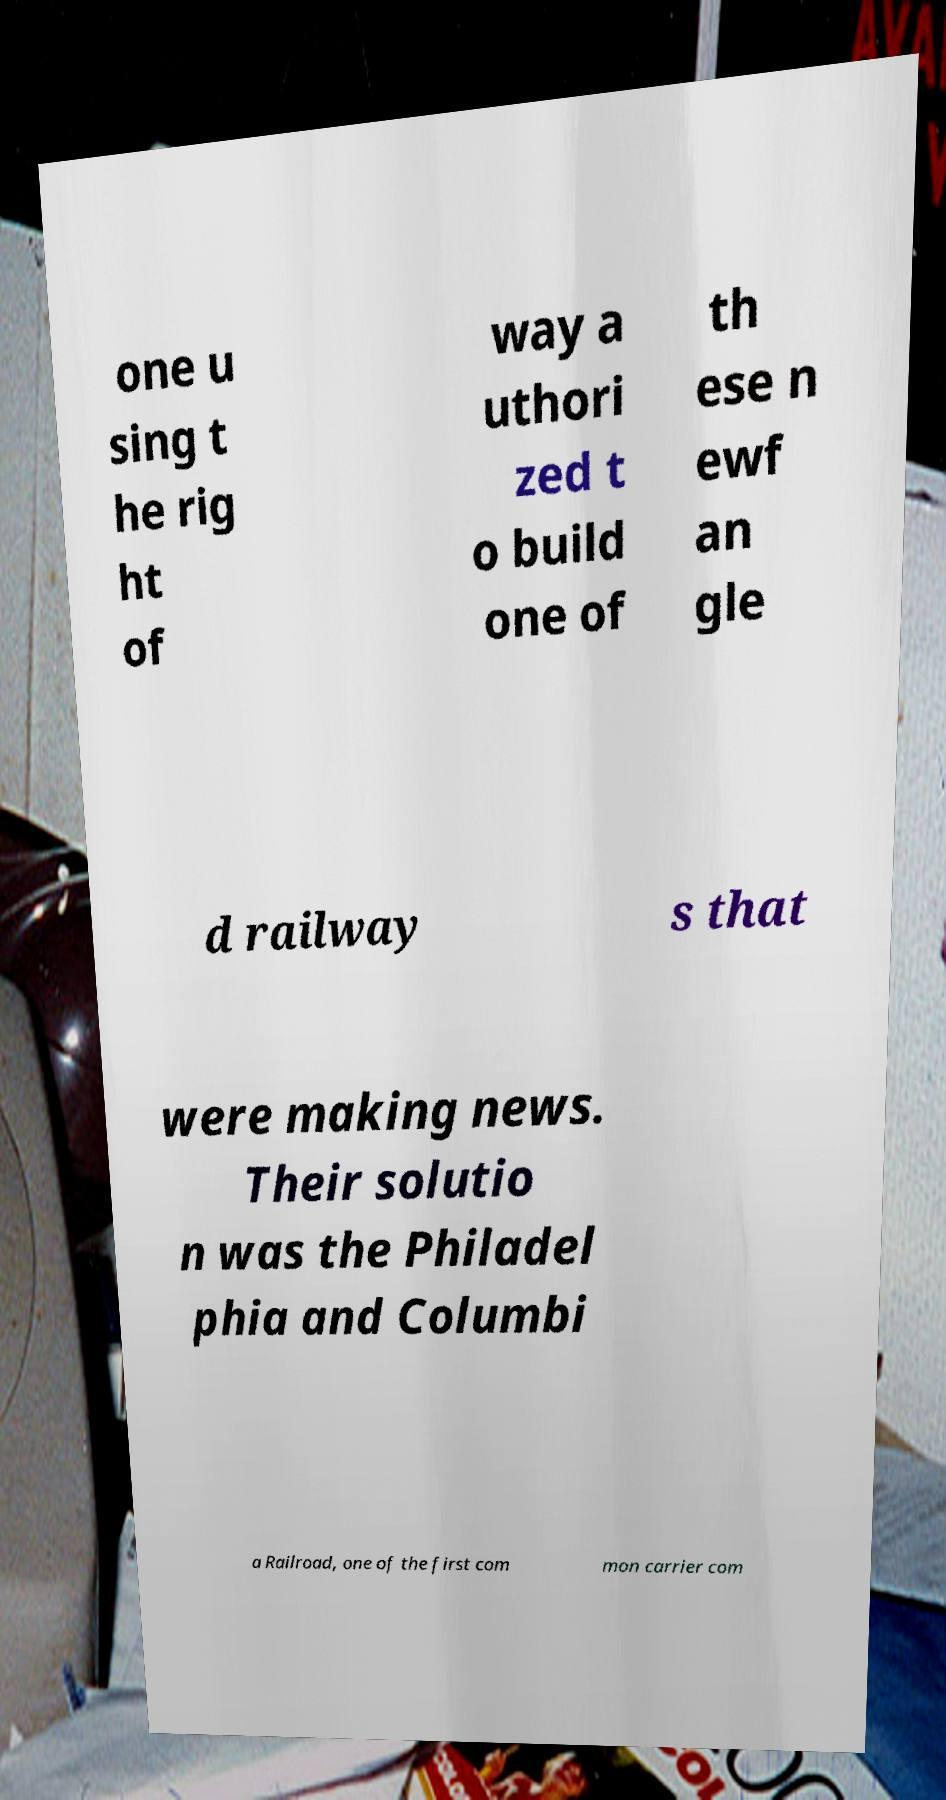Please read and relay the text visible in this image. What does it say? one u sing t he rig ht of way a uthori zed t o build one of th ese n ewf an gle d railway s that were making news. Their solutio n was the Philadel phia and Columbi a Railroad, one of the first com mon carrier com 